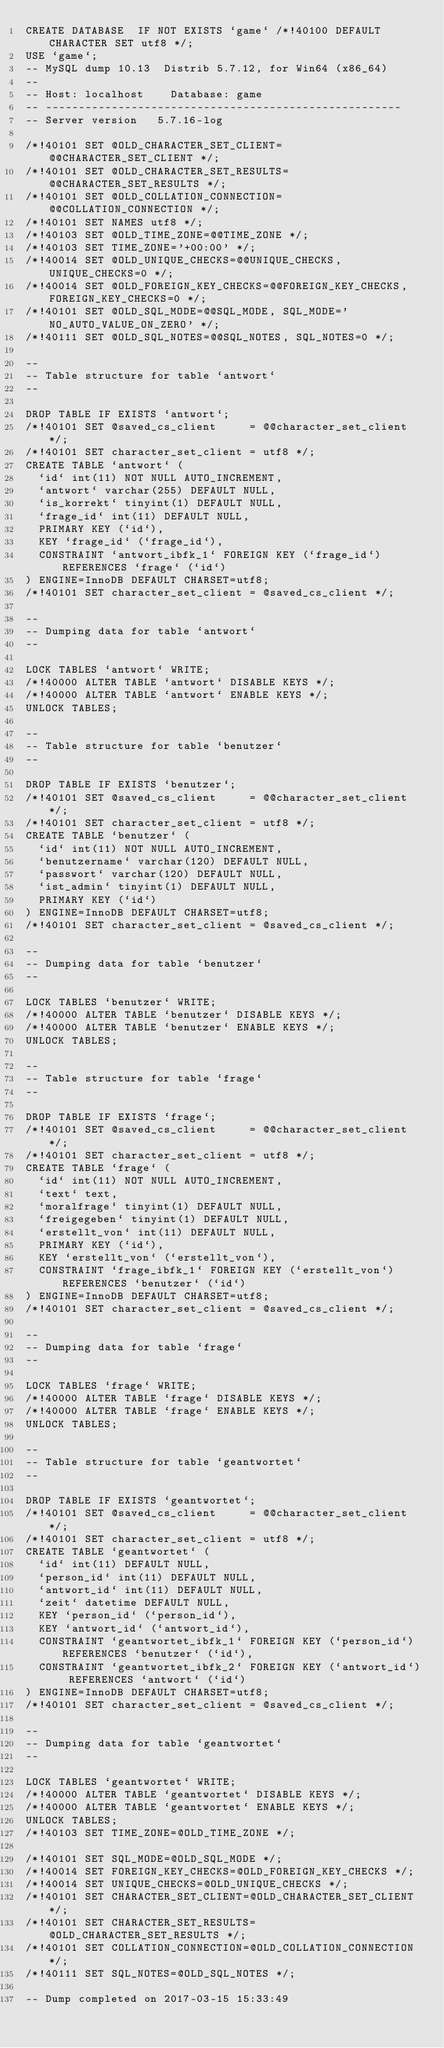<code> <loc_0><loc_0><loc_500><loc_500><_SQL_>CREATE DATABASE  IF NOT EXISTS `game` /*!40100 DEFAULT CHARACTER SET utf8 */;
USE `game`;
-- MySQL dump 10.13  Distrib 5.7.12, for Win64 (x86_64)
--
-- Host: localhost    Database: game
-- ------------------------------------------------------
-- Server version	5.7.16-log

/*!40101 SET @OLD_CHARACTER_SET_CLIENT=@@CHARACTER_SET_CLIENT */;
/*!40101 SET @OLD_CHARACTER_SET_RESULTS=@@CHARACTER_SET_RESULTS */;
/*!40101 SET @OLD_COLLATION_CONNECTION=@@COLLATION_CONNECTION */;
/*!40101 SET NAMES utf8 */;
/*!40103 SET @OLD_TIME_ZONE=@@TIME_ZONE */;
/*!40103 SET TIME_ZONE='+00:00' */;
/*!40014 SET @OLD_UNIQUE_CHECKS=@@UNIQUE_CHECKS, UNIQUE_CHECKS=0 */;
/*!40014 SET @OLD_FOREIGN_KEY_CHECKS=@@FOREIGN_KEY_CHECKS, FOREIGN_KEY_CHECKS=0 */;
/*!40101 SET @OLD_SQL_MODE=@@SQL_MODE, SQL_MODE='NO_AUTO_VALUE_ON_ZERO' */;
/*!40111 SET @OLD_SQL_NOTES=@@SQL_NOTES, SQL_NOTES=0 */;

--
-- Table structure for table `antwort`
--

DROP TABLE IF EXISTS `antwort`;
/*!40101 SET @saved_cs_client     = @@character_set_client */;
/*!40101 SET character_set_client = utf8 */;
CREATE TABLE `antwort` (
  `id` int(11) NOT NULL AUTO_INCREMENT,
  `antwort` varchar(255) DEFAULT NULL,
  `is_korrekt` tinyint(1) DEFAULT NULL,
  `frage_id` int(11) DEFAULT NULL,
  PRIMARY KEY (`id`),
  KEY `frage_id` (`frage_id`),
  CONSTRAINT `antwort_ibfk_1` FOREIGN KEY (`frage_id`) REFERENCES `frage` (`id`)
) ENGINE=InnoDB DEFAULT CHARSET=utf8;
/*!40101 SET character_set_client = @saved_cs_client */;

--
-- Dumping data for table `antwort`
--

LOCK TABLES `antwort` WRITE;
/*!40000 ALTER TABLE `antwort` DISABLE KEYS */;
/*!40000 ALTER TABLE `antwort` ENABLE KEYS */;
UNLOCK TABLES;

--
-- Table structure for table `benutzer`
--

DROP TABLE IF EXISTS `benutzer`;
/*!40101 SET @saved_cs_client     = @@character_set_client */;
/*!40101 SET character_set_client = utf8 */;
CREATE TABLE `benutzer` (
  `id` int(11) NOT NULL AUTO_INCREMENT,
  `benutzername` varchar(120) DEFAULT NULL,
  `passwort` varchar(120) DEFAULT NULL,
  `ist_admin` tinyint(1) DEFAULT NULL,
  PRIMARY KEY (`id`)
) ENGINE=InnoDB DEFAULT CHARSET=utf8;
/*!40101 SET character_set_client = @saved_cs_client */;

--
-- Dumping data for table `benutzer`
--

LOCK TABLES `benutzer` WRITE;
/*!40000 ALTER TABLE `benutzer` DISABLE KEYS */;
/*!40000 ALTER TABLE `benutzer` ENABLE KEYS */;
UNLOCK TABLES;

--
-- Table structure for table `frage`
--

DROP TABLE IF EXISTS `frage`;
/*!40101 SET @saved_cs_client     = @@character_set_client */;
/*!40101 SET character_set_client = utf8 */;
CREATE TABLE `frage` (
  `id` int(11) NOT NULL AUTO_INCREMENT,
  `text` text,
  `moralfrage` tinyint(1) DEFAULT NULL,
  `freigegeben` tinyint(1) DEFAULT NULL,
  `erstellt_von` int(11) DEFAULT NULL,
  PRIMARY KEY (`id`),
  KEY `erstellt_von` (`erstellt_von`),
  CONSTRAINT `frage_ibfk_1` FOREIGN KEY (`erstellt_von`) REFERENCES `benutzer` (`id`)
) ENGINE=InnoDB DEFAULT CHARSET=utf8;
/*!40101 SET character_set_client = @saved_cs_client */;

--
-- Dumping data for table `frage`
--

LOCK TABLES `frage` WRITE;
/*!40000 ALTER TABLE `frage` DISABLE KEYS */;
/*!40000 ALTER TABLE `frage` ENABLE KEYS */;
UNLOCK TABLES;

--
-- Table structure for table `geantwortet`
--

DROP TABLE IF EXISTS `geantwortet`;
/*!40101 SET @saved_cs_client     = @@character_set_client */;
/*!40101 SET character_set_client = utf8 */;
CREATE TABLE `geantwortet` (
  `id` int(11) DEFAULT NULL,
  `person_id` int(11) DEFAULT NULL,
  `antwort_id` int(11) DEFAULT NULL,
  `zeit` datetime DEFAULT NULL,
  KEY `person_id` (`person_id`),
  KEY `antwort_id` (`antwort_id`),
  CONSTRAINT `geantwortet_ibfk_1` FOREIGN KEY (`person_id`) REFERENCES `benutzer` (`id`),
  CONSTRAINT `geantwortet_ibfk_2` FOREIGN KEY (`antwort_id`) REFERENCES `antwort` (`id`)
) ENGINE=InnoDB DEFAULT CHARSET=utf8;
/*!40101 SET character_set_client = @saved_cs_client */;

--
-- Dumping data for table `geantwortet`
--

LOCK TABLES `geantwortet` WRITE;
/*!40000 ALTER TABLE `geantwortet` DISABLE KEYS */;
/*!40000 ALTER TABLE `geantwortet` ENABLE KEYS */;
UNLOCK TABLES;
/*!40103 SET TIME_ZONE=@OLD_TIME_ZONE */;

/*!40101 SET SQL_MODE=@OLD_SQL_MODE */;
/*!40014 SET FOREIGN_KEY_CHECKS=@OLD_FOREIGN_KEY_CHECKS */;
/*!40014 SET UNIQUE_CHECKS=@OLD_UNIQUE_CHECKS */;
/*!40101 SET CHARACTER_SET_CLIENT=@OLD_CHARACTER_SET_CLIENT */;
/*!40101 SET CHARACTER_SET_RESULTS=@OLD_CHARACTER_SET_RESULTS */;
/*!40101 SET COLLATION_CONNECTION=@OLD_COLLATION_CONNECTION */;
/*!40111 SET SQL_NOTES=@OLD_SQL_NOTES */;

-- Dump completed on 2017-03-15 15:33:49
</code> 